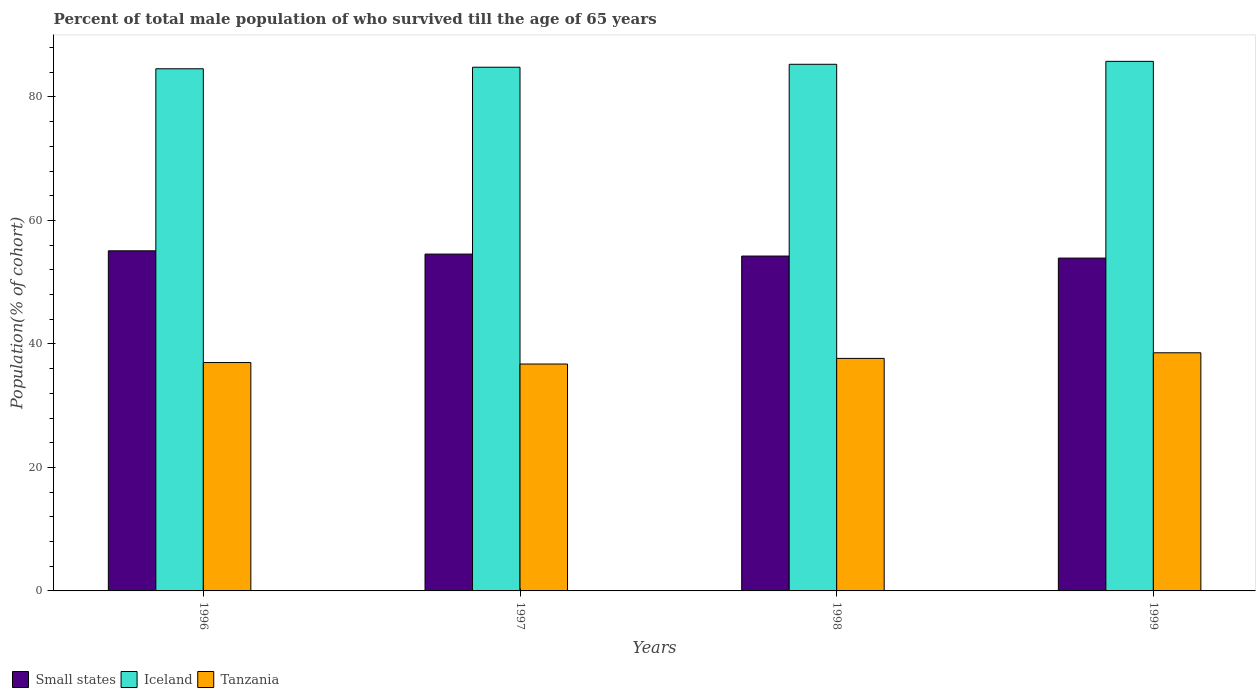How many groups of bars are there?
Offer a terse response. 4. Are the number of bars per tick equal to the number of legend labels?
Your answer should be very brief. Yes. Are the number of bars on each tick of the X-axis equal?
Your answer should be compact. Yes. How many bars are there on the 4th tick from the left?
Your answer should be compact. 3. How many bars are there on the 4th tick from the right?
Your answer should be compact. 3. What is the percentage of total male population who survived till the age of 65 years in Iceland in 1996?
Offer a very short reply. 84.56. Across all years, what is the maximum percentage of total male population who survived till the age of 65 years in Small states?
Offer a very short reply. 55.08. Across all years, what is the minimum percentage of total male population who survived till the age of 65 years in Small states?
Make the answer very short. 53.9. In which year was the percentage of total male population who survived till the age of 65 years in Small states minimum?
Your answer should be very brief. 1999. What is the total percentage of total male population who survived till the age of 65 years in Iceland in the graph?
Offer a very short reply. 340.41. What is the difference between the percentage of total male population who survived till the age of 65 years in Small states in 1996 and that in 1999?
Provide a succinct answer. 1.18. What is the difference between the percentage of total male population who survived till the age of 65 years in Tanzania in 1998 and the percentage of total male population who survived till the age of 65 years in Iceland in 1997?
Offer a very short reply. -47.15. What is the average percentage of total male population who survived till the age of 65 years in Small states per year?
Provide a succinct answer. 54.44. In the year 1998, what is the difference between the percentage of total male population who survived till the age of 65 years in Iceland and percentage of total male population who survived till the age of 65 years in Small states?
Your answer should be very brief. 31.05. What is the ratio of the percentage of total male population who survived till the age of 65 years in Tanzania in 1996 to that in 1999?
Your answer should be compact. 0.96. Is the percentage of total male population who survived till the age of 65 years in Small states in 1996 less than that in 1998?
Ensure brevity in your answer.  No. Is the difference between the percentage of total male population who survived till the age of 65 years in Iceland in 1996 and 1998 greater than the difference between the percentage of total male population who survived till the age of 65 years in Small states in 1996 and 1998?
Your response must be concise. No. What is the difference between the highest and the second highest percentage of total male population who survived till the age of 65 years in Iceland?
Your answer should be very brief. 0.48. What is the difference between the highest and the lowest percentage of total male population who survived till the age of 65 years in Iceland?
Your response must be concise. 1.2. Is the sum of the percentage of total male population who survived till the age of 65 years in Tanzania in 1996 and 1998 greater than the maximum percentage of total male population who survived till the age of 65 years in Iceland across all years?
Provide a succinct answer. No. What does the 1st bar from the left in 1996 represents?
Your answer should be very brief. Small states. What does the 1st bar from the right in 1997 represents?
Ensure brevity in your answer.  Tanzania. Is it the case that in every year, the sum of the percentage of total male population who survived till the age of 65 years in Tanzania and percentage of total male population who survived till the age of 65 years in Iceland is greater than the percentage of total male population who survived till the age of 65 years in Small states?
Give a very brief answer. Yes. How many bars are there?
Ensure brevity in your answer.  12. What is the difference between two consecutive major ticks on the Y-axis?
Your response must be concise. 20. Are the values on the major ticks of Y-axis written in scientific E-notation?
Ensure brevity in your answer.  No. Where does the legend appear in the graph?
Your answer should be very brief. Bottom left. How are the legend labels stacked?
Your answer should be very brief. Horizontal. What is the title of the graph?
Ensure brevity in your answer.  Percent of total male population of who survived till the age of 65 years. Does "Vanuatu" appear as one of the legend labels in the graph?
Provide a short and direct response. No. What is the label or title of the X-axis?
Your answer should be compact. Years. What is the label or title of the Y-axis?
Your response must be concise. Population(% of cohort). What is the Population(% of cohort) of Small states in 1996?
Your answer should be very brief. 55.08. What is the Population(% of cohort) of Iceland in 1996?
Your response must be concise. 84.56. What is the Population(% of cohort) in Tanzania in 1996?
Offer a terse response. 36.98. What is the Population(% of cohort) in Small states in 1997?
Give a very brief answer. 54.55. What is the Population(% of cohort) in Iceland in 1997?
Your answer should be compact. 84.81. What is the Population(% of cohort) in Tanzania in 1997?
Provide a short and direct response. 36.74. What is the Population(% of cohort) in Small states in 1998?
Your answer should be compact. 54.23. What is the Population(% of cohort) of Iceland in 1998?
Make the answer very short. 85.28. What is the Population(% of cohort) in Tanzania in 1998?
Your answer should be very brief. 37.66. What is the Population(% of cohort) in Small states in 1999?
Your response must be concise. 53.9. What is the Population(% of cohort) in Iceland in 1999?
Provide a short and direct response. 85.76. What is the Population(% of cohort) in Tanzania in 1999?
Keep it short and to the point. 38.57. Across all years, what is the maximum Population(% of cohort) in Small states?
Your answer should be compact. 55.08. Across all years, what is the maximum Population(% of cohort) in Iceland?
Offer a terse response. 85.76. Across all years, what is the maximum Population(% of cohort) in Tanzania?
Provide a succinct answer. 38.57. Across all years, what is the minimum Population(% of cohort) of Small states?
Ensure brevity in your answer.  53.9. Across all years, what is the minimum Population(% of cohort) in Iceland?
Keep it short and to the point. 84.56. Across all years, what is the minimum Population(% of cohort) of Tanzania?
Give a very brief answer. 36.74. What is the total Population(% of cohort) of Small states in the graph?
Keep it short and to the point. 217.76. What is the total Population(% of cohort) of Iceland in the graph?
Your answer should be very brief. 340.41. What is the total Population(% of cohort) of Tanzania in the graph?
Your answer should be compact. 149.95. What is the difference between the Population(% of cohort) of Small states in 1996 and that in 1997?
Make the answer very short. 0.53. What is the difference between the Population(% of cohort) in Iceland in 1996 and that in 1997?
Make the answer very short. -0.25. What is the difference between the Population(% of cohort) in Tanzania in 1996 and that in 1997?
Give a very brief answer. 0.24. What is the difference between the Population(% of cohort) of Small states in 1996 and that in 1998?
Offer a terse response. 0.85. What is the difference between the Population(% of cohort) of Iceland in 1996 and that in 1998?
Offer a very short reply. -0.73. What is the difference between the Population(% of cohort) in Tanzania in 1996 and that in 1998?
Offer a terse response. -0.67. What is the difference between the Population(% of cohort) of Small states in 1996 and that in 1999?
Keep it short and to the point. 1.18. What is the difference between the Population(% of cohort) in Iceland in 1996 and that in 1999?
Provide a short and direct response. -1.2. What is the difference between the Population(% of cohort) in Tanzania in 1996 and that in 1999?
Your response must be concise. -1.58. What is the difference between the Population(% of cohort) of Small states in 1997 and that in 1998?
Give a very brief answer. 0.32. What is the difference between the Population(% of cohort) of Iceland in 1997 and that in 1998?
Provide a short and direct response. -0.48. What is the difference between the Population(% of cohort) of Tanzania in 1997 and that in 1998?
Your response must be concise. -0.91. What is the difference between the Population(% of cohort) in Small states in 1997 and that in 1999?
Offer a very short reply. 0.65. What is the difference between the Population(% of cohort) in Iceland in 1997 and that in 1999?
Provide a short and direct response. -0.95. What is the difference between the Population(% of cohort) in Tanzania in 1997 and that in 1999?
Your response must be concise. -1.82. What is the difference between the Population(% of cohort) of Small states in 1998 and that in 1999?
Provide a succinct answer. 0.33. What is the difference between the Population(% of cohort) in Iceland in 1998 and that in 1999?
Make the answer very short. -0.48. What is the difference between the Population(% of cohort) in Tanzania in 1998 and that in 1999?
Your answer should be very brief. -0.91. What is the difference between the Population(% of cohort) of Small states in 1996 and the Population(% of cohort) of Iceland in 1997?
Your response must be concise. -29.73. What is the difference between the Population(% of cohort) in Small states in 1996 and the Population(% of cohort) in Tanzania in 1997?
Provide a succinct answer. 18.33. What is the difference between the Population(% of cohort) of Iceland in 1996 and the Population(% of cohort) of Tanzania in 1997?
Make the answer very short. 47.81. What is the difference between the Population(% of cohort) in Small states in 1996 and the Population(% of cohort) in Iceland in 1998?
Offer a terse response. -30.21. What is the difference between the Population(% of cohort) of Small states in 1996 and the Population(% of cohort) of Tanzania in 1998?
Your answer should be compact. 17.42. What is the difference between the Population(% of cohort) of Iceland in 1996 and the Population(% of cohort) of Tanzania in 1998?
Provide a short and direct response. 46.9. What is the difference between the Population(% of cohort) in Small states in 1996 and the Population(% of cohort) in Iceland in 1999?
Give a very brief answer. -30.68. What is the difference between the Population(% of cohort) in Small states in 1996 and the Population(% of cohort) in Tanzania in 1999?
Provide a succinct answer. 16.51. What is the difference between the Population(% of cohort) of Iceland in 1996 and the Population(% of cohort) of Tanzania in 1999?
Your answer should be compact. 45.99. What is the difference between the Population(% of cohort) of Small states in 1997 and the Population(% of cohort) of Iceland in 1998?
Ensure brevity in your answer.  -30.74. What is the difference between the Population(% of cohort) of Small states in 1997 and the Population(% of cohort) of Tanzania in 1998?
Provide a succinct answer. 16.89. What is the difference between the Population(% of cohort) of Iceland in 1997 and the Population(% of cohort) of Tanzania in 1998?
Your response must be concise. 47.15. What is the difference between the Population(% of cohort) in Small states in 1997 and the Population(% of cohort) in Iceland in 1999?
Offer a very short reply. -31.21. What is the difference between the Population(% of cohort) in Small states in 1997 and the Population(% of cohort) in Tanzania in 1999?
Provide a succinct answer. 15.98. What is the difference between the Population(% of cohort) of Iceland in 1997 and the Population(% of cohort) of Tanzania in 1999?
Make the answer very short. 46.24. What is the difference between the Population(% of cohort) of Small states in 1998 and the Population(% of cohort) of Iceland in 1999?
Make the answer very short. -31.53. What is the difference between the Population(% of cohort) in Small states in 1998 and the Population(% of cohort) in Tanzania in 1999?
Keep it short and to the point. 15.66. What is the difference between the Population(% of cohort) of Iceland in 1998 and the Population(% of cohort) of Tanzania in 1999?
Your answer should be compact. 46.72. What is the average Population(% of cohort) in Small states per year?
Offer a very short reply. 54.44. What is the average Population(% of cohort) of Iceland per year?
Keep it short and to the point. 85.1. What is the average Population(% of cohort) in Tanzania per year?
Offer a terse response. 37.49. In the year 1996, what is the difference between the Population(% of cohort) of Small states and Population(% of cohort) of Iceland?
Ensure brevity in your answer.  -29.48. In the year 1996, what is the difference between the Population(% of cohort) of Small states and Population(% of cohort) of Tanzania?
Offer a very short reply. 18.09. In the year 1996, what is the difference between the Population(% of cohort) of Iceland and Population(% of cohort) of Tanzania?
Keep it short and to the point. 47.57. In the year 1997, what is the difference between the Population(% of cohort) of Small states and Population(% of cohort) of Iceland?
Your answer should be compact. -30.26. In the year 1997, what is the difference between the Population(% of cohort) of Small states and Population(% of cohort) of Tanzania?
Ensure brevity in your answer.  17.8. In the year 1997, what is the difference between the Population(% of cohort) of Iceland and Population(% of cohort) of Tanzania?
Offer a very short reply. 48.06. In the year 1998, what is the difference between the Population(% of cohort) of Small states and Population(% of cohort) of Iceland?
Make the answer very short. -31.05. In the year 1998, what is the difference between the Population(% of cohort) of Small states and Population(% of cohort) of Tanzania?
Your answer should be compact. 16.57. In the year 1998, what is the difference between the Population(% of cohort) in Iceland and Population(% of cohort) in Tanzania?
Ensure brevity in your answer.  47.63. In the year 1999, what is the difference between the Population(% of cohort) in Small states and Population(% of cohort) in Iceland?
Make the answer very short. -31.86. In the year 1999, what is the difference between the Population(% of cohort) of Small states and Population(% of cohort) of Tanzania?
Give a very brief answer. 15.33. In the year 1999, what is the difference between the Population(% of cohort) in Iceland and Population(% of cohort) in Tanzania?
Make the answer very short. 47.19. What is the ratio of the Population(% of cohort) of Small states in 1996 to that in 1997?
Provide a short and direct response. 1.01. What is the ratio of the Population(% of cohort) in Iceland in 1996 to that in 1997?
Ensure brevity in your answer.  1. What is the ratio of the Population(% of cohort) in Tanzania in 1996 to that in 1997?
Offer a very short reply. 1.01. What is the ratio of the Population(% of cohort) of Small states in 1996 to that in 1998?
Offer a very short reply. 1.02. What is the ratio of the Population(% of cohort) in Iceland in 1996 to that in 1998?
Your answer should be very brief. 0.99. What is the ratio of the Population(% of cohort) of Tanzania in 1996 to that in 1998?
Your answer should be very brief. 0.98. What is the ratio of the Population(% of cohort) in Small states in 1996 to that in 1999?
Your answer should be very brief. 1.02. What is the ratio of the Population(% of cohort) of Iceland in 1996 to that in 1999?
Provide a short and direct response. 0.99. What is the ratio of the Population(% of cohort) of Tanzania in 1996 to that in 1999?
Ensure brevity in your answer.  0.96. What is the ratio of the Population(% of cohort) of Small states in 1997 to that in 1998?
Your answer should be compact. 1.01. What is the ratio of the Population(% of cohort) in Iceland in 1997 to that in 1998?
Make the answer very short. 0.99. What is the ratio of the Population(% of cohort) in Tanzania in 1997 to that in 1998?
Your response must be concise. 0.98. What is the ratio of the Population(% of cohort) in Small states in 1997 to that in 1999?
Your response must be concise. 1.01. What is the ratio of the Population(% of cohort) in Iceland in 1997 to that in 1999?
Your response must be concise. 0.99. What is the ratio of the Population(% of cohort) in Tanzania in 1997 to that in 1999?
Offer a very short reply. 0.95. What is the ratio of the Population(% of cohort) in Iceland in 1998 to that in 1999?
Provide a short and direct response. 0.99. What is the ratio of the Population(% of cohort) of Tanzania in 1998 to that in 1999?
Provide a succinct answer. 0.98. What is the difference between the highest and the second highest Population(% of cohort) in Small states?
Ensure brevity in your answer.  0.53. What is the difference between the highest and the second highest Population(% of cohort) in Iceland?
Ensure brevity in your answer.  0.48. What is the difference between the highest and the second highest Population(% of cohort) of Tanzania?
Provide a succinct answer. 0.91. What is the difference between the highest and the lowest Population(% of cohort) in Small states?
Keep it short and to the point. 1.18. What is the difference between the highest and the lowest Population(% of cohort) of Iceland?
Offer a very short reply. 1.2. What is the difference between the highest and the lowest Population(% of cohort) in Tanzania?
Offer a very short reply. 1.82. 